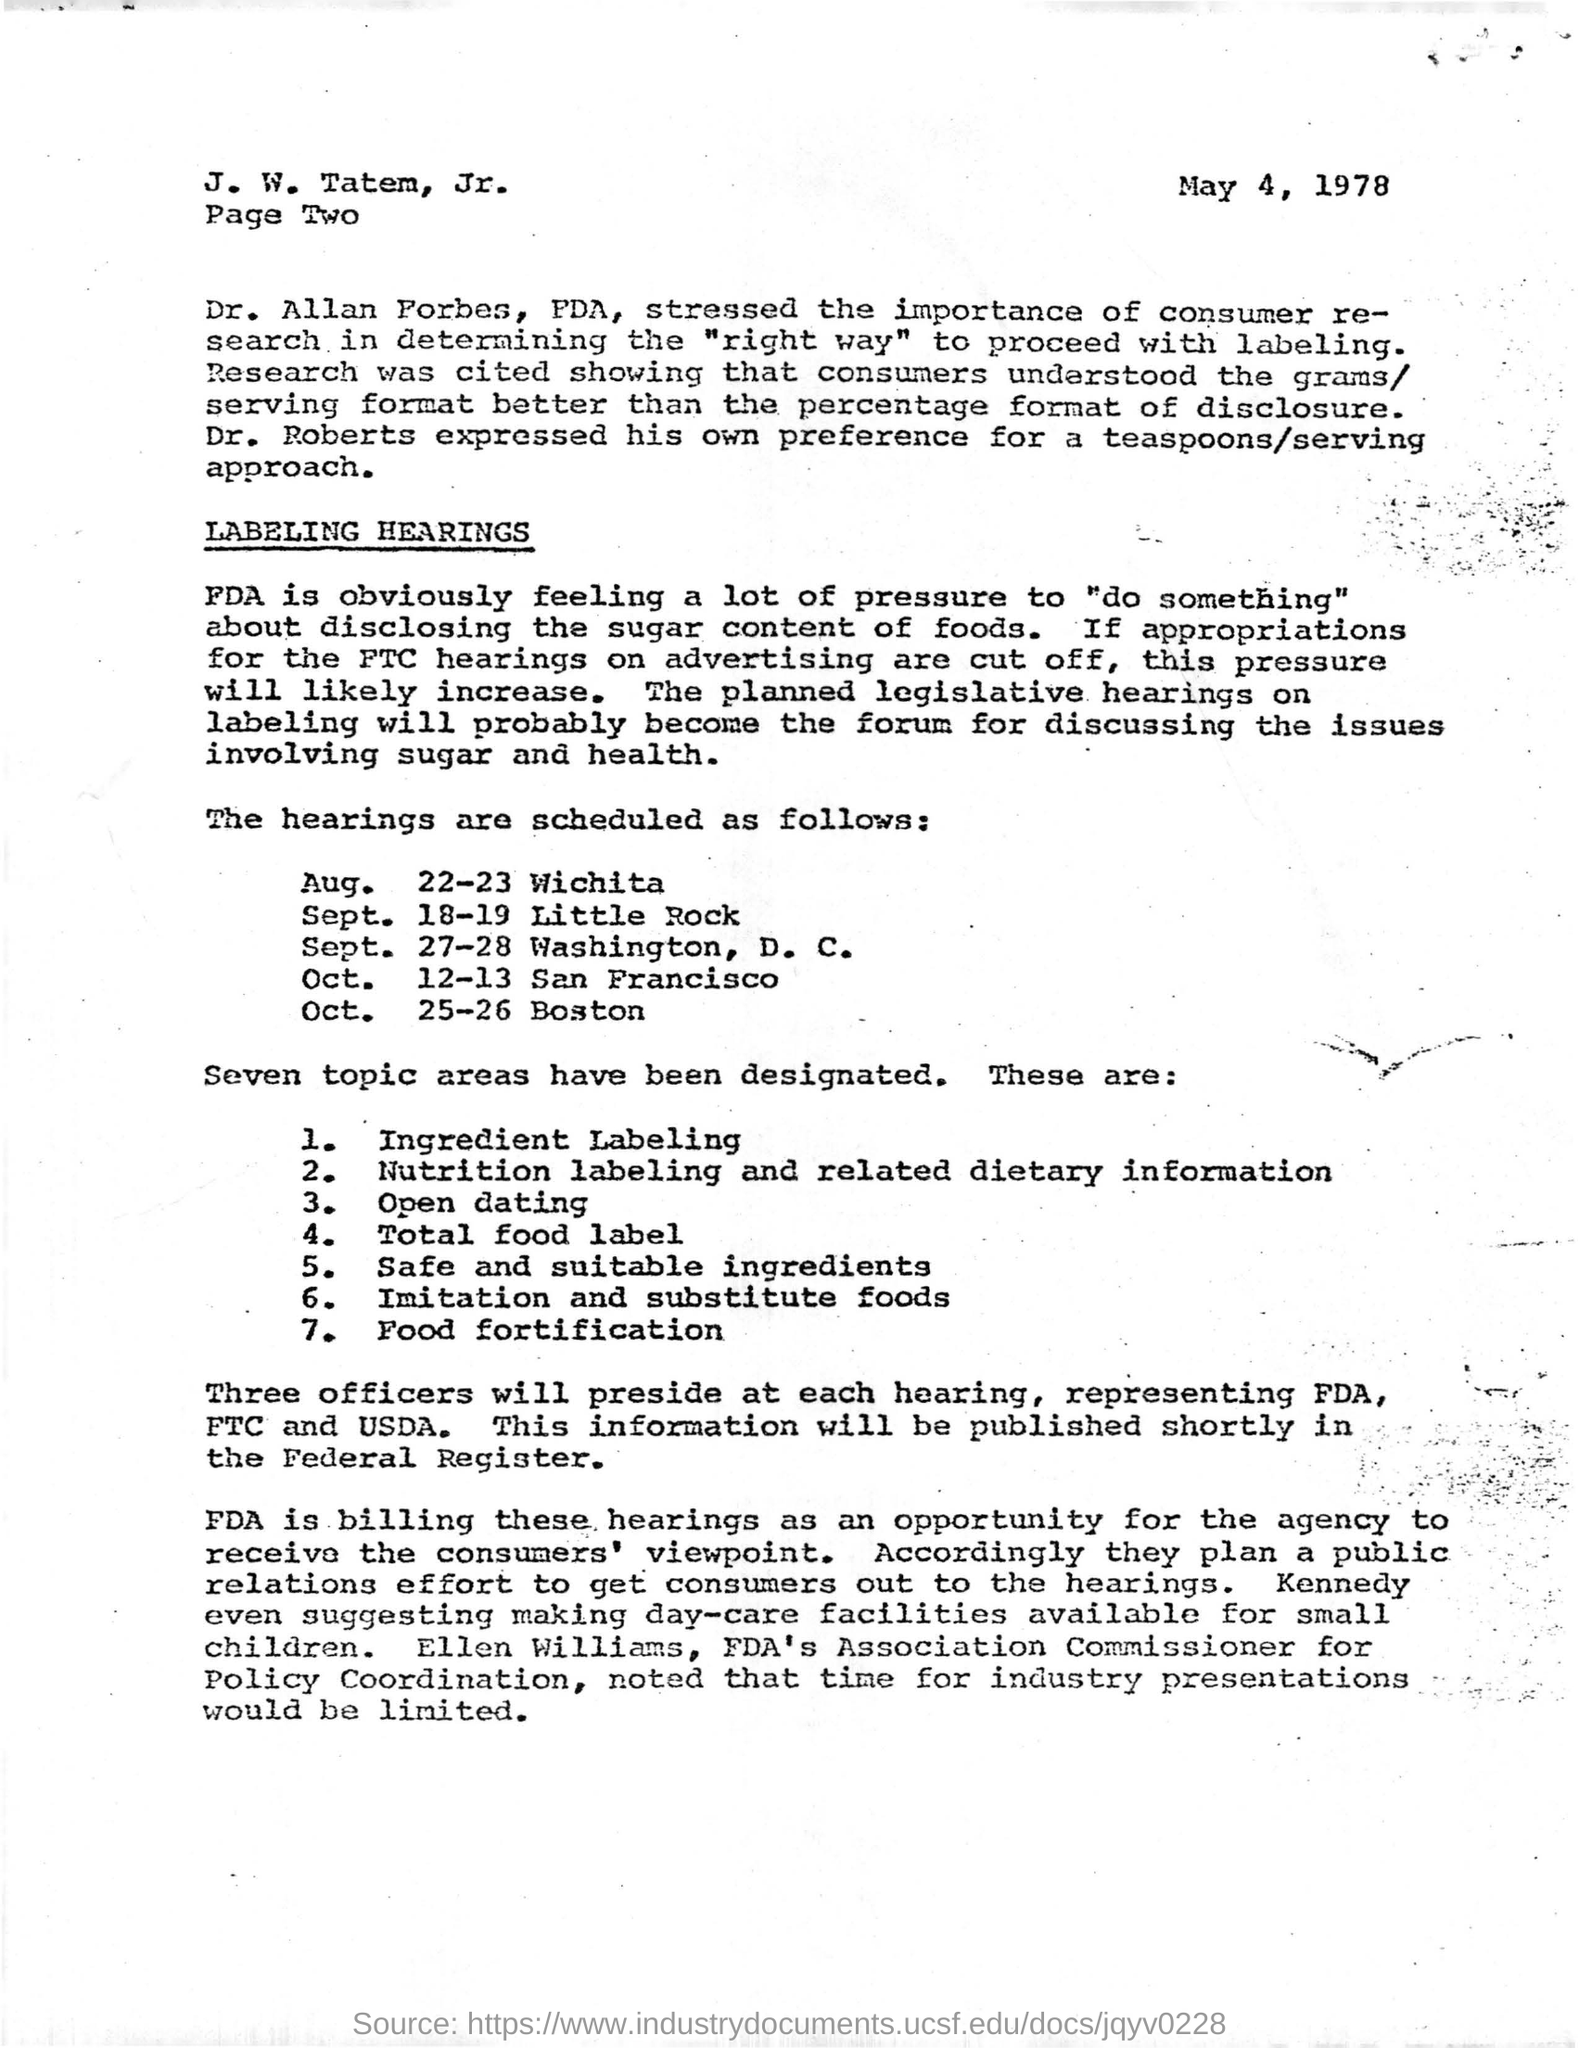Mention the date mentioned in this letter?
Ensure brevity in your answer.  May 4, 1978. Who expressed that his own preference for a teaspoons/serving approach?
Offer a very short reply. Dr. roberts. Who streesed the importance of consumer research in determining the "right way" to proceed with labeling?
Keep it short and to the point. Dr. Allan Forbes. Mention the location which hearings are scheduled on oct 12-13?
Offer a terse response. San Francisco. Who is the fda's association commissioner for policy coordination?
Give a very brief answer. Ellen williams. 